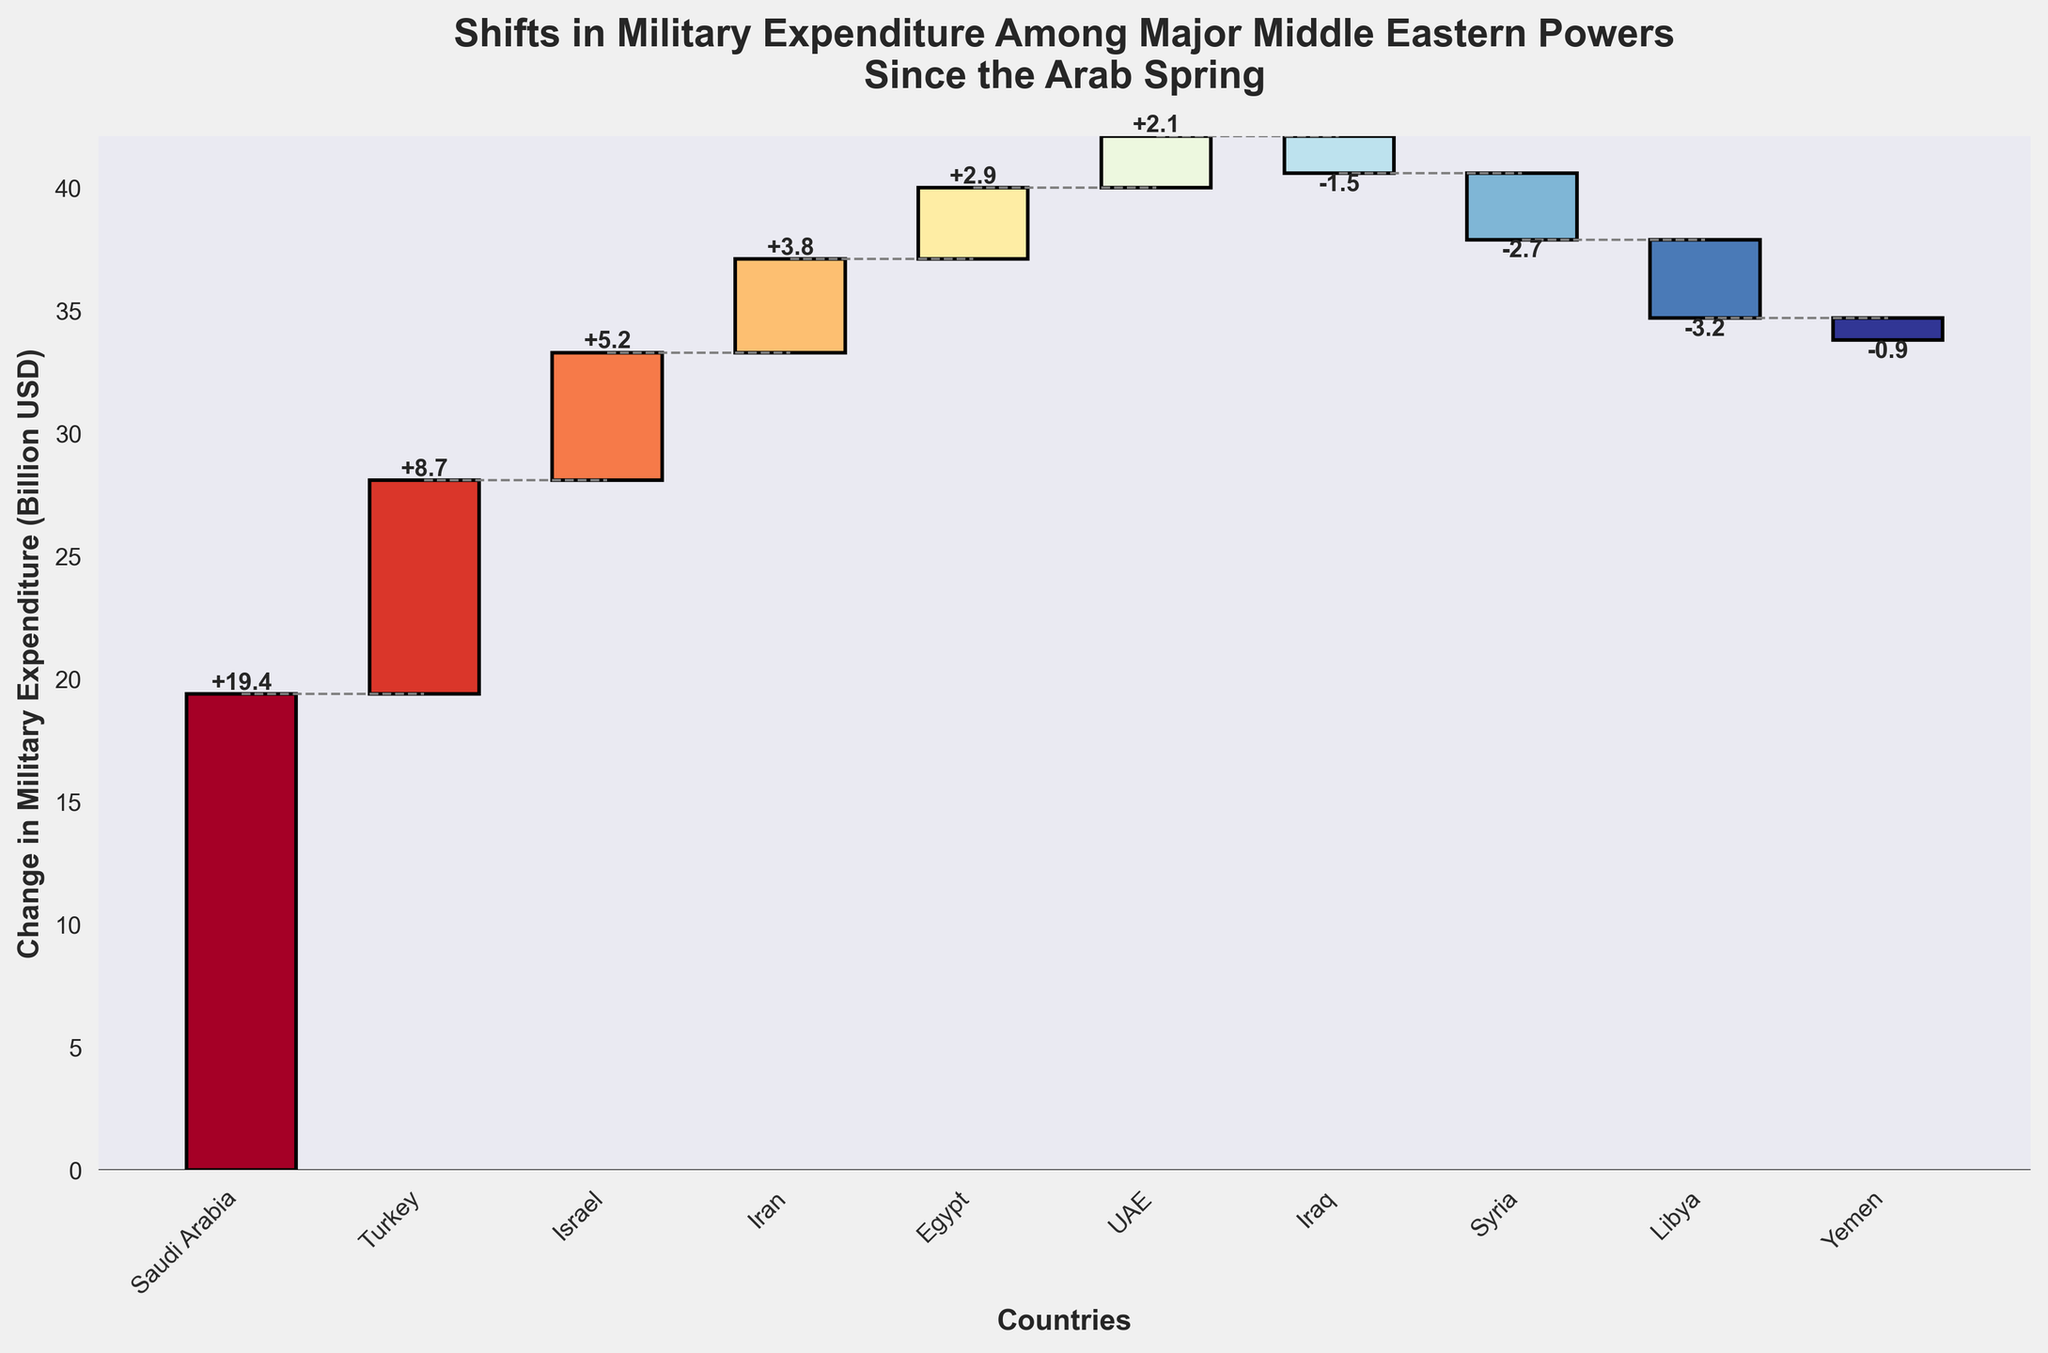How many countries are represented in the chart? Count the number of unique countries listed on the x-axis.
Answer: 10 Which country has the biggest increase in military expenditure? Look for the tallest positive bar in the chart. It is labeled "Saudi Arabia" with an increase.
Answer: Saudi Arabia Which country had the largest decrease in military expenditure? Identify the country with the tallest negative bar in the chart. It is labeled "Libya".
Answer: Libya What is the total increase in military expenditure for countries that had a positive change? Sum the positive changes: 19.4 (Saudi Arabia) + 8.7 (Turkey) + 5.2 (Israel) + 3.8 (Iran) + 2.9 (Egypt) + 2.1 (UAE) = 42.1.
Answer: 42.1 billion USD What is the total decrease in military expenditure for countries that had a negative change? Sum the negative changes: -1.5 (Iraq) + -2.7 (Syria) + -3.2 (Libya) + -0.9 (Yemen) = -8.3.
Answer: 8.3 billion USD Which country saw a larger change in military expenditure, Turkey or Iran? Compare the changes for Turkey (8.7) and Iran (3.8). Turkey's change is larger.
Answer: Turkey By how much did the combined military expenditure of Israel and Egypt change? Sum the changes for Israel (5.2) and Egypt (2.9): 5.2 + 2.9 = 8.1.
Answer: 8.1 billion USD Which countries had a positive change in military expenditure? List the countries with a positive bar in the chart: Saudi Arabia, Turkey, Israel, Iran, Egypt, UAE.
Answer: Saudi Arabia, Turkey, Israel, Iran, Egypt, UAE Is there any country whose change in military expenditure is less than -1 billion USD but greater than -2 billion USD? Look for countries with values between -1 and -2 billion USD, which is Iraq with -1.5 billion USD.
Answer: Iraq 